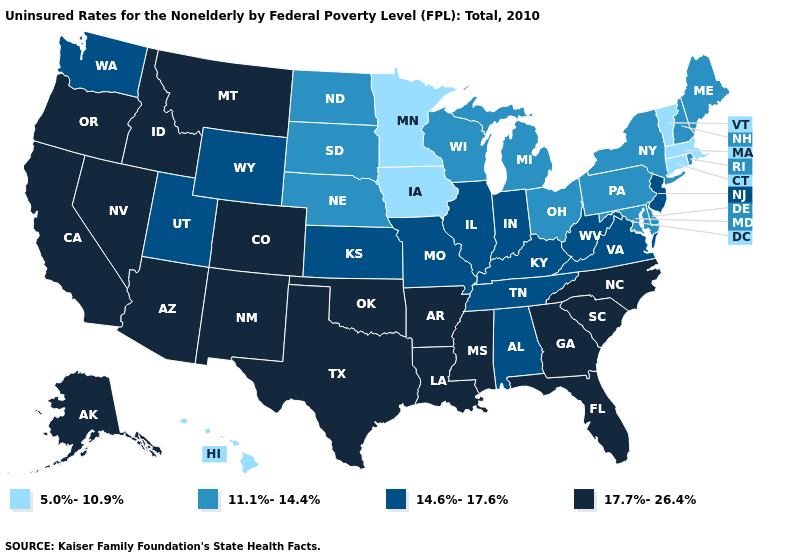Name the states that have a value in the range 14.6%-17.6%?
Quick response, please. Alabama, Illinois, Indiana, Kansas, Kentucky, Missouri, New Jersey, Tennessee, Utah, Virginia, Washington, West Virginia, Wyoming. Name the states that have a value in the range 17.7%-26.4%?
Short answer required. Alaska, Arizona, Arkansas, California, Colorado, Florida, Georgia, Idaho, Louisiana, Mississippi, Montana, Nevada, New Mexico, North Carolina, Oklahoma, Oregon, South Carolina, Texas. What is the value of Ohio?
Be succinct. 11.1%-14.4%. What is the value of West Virginia?
Answer briefly. 14.6%-17.6%. Does Iowa have a lower value than Minnesota?
Concise answer only. No. What is the value of Maine?
Answer briefly. 11.1%-14.4%. What is the highest value in the USA?
Quick response, please. 17.7%-26.4%. What is the value of Pennsylvania?
Concise answer only. 11.1%-14.4%. Which states hav the highest value in the Northeast?
Write a very short answer. New Jersey. What is the value of Alabama?
Keep it brief. 14.6%-17.6%. Among the states that border Michigan , which have the highest value?
Quick response, please. Indiana. Name the states that have a value in the range 11.1%-14.4%?
Concise answer only. Delaware, Maine, Maryland, Michigan, Nebraska, New Hampshire, New York, North Dakota, Ohio, Pennsylvania, Rhode Island, South Dakota, Wisconsin. What is the lowest value in the Northeast?
Give a very brief answer. 5.0%-10.9%. What is the value of Mississippi?
Give a very brief answer. 17.7%-26.4%. What is the value of New York?
Give a very brief answer. 11.1%-14.4%. 